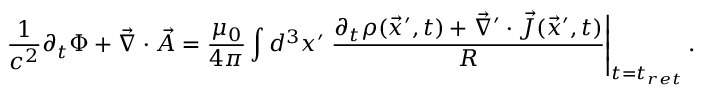Convert formula to latex. <formula><loc_0><loc_0><loc_500><loc_500>\frac { 1 } { c ^ { 2 } } \partial _ { t } \Phi + \vec { \nabla } \cdot \vec { A } = \frac { \mu _ { 0 } } { 4 \pi } \int d ^ { 3 } x ^ { \prime } \frac { \partial _ { t } \rho ( \vec { x } ^ { \prime } , t ) + \vec { \nabla } ^ { \prime } \cdot \vec { J } ( \vec { x } ^ { \prime } , t ) } { R } \right | _ { t = t _ { r e t } } .</formula> 